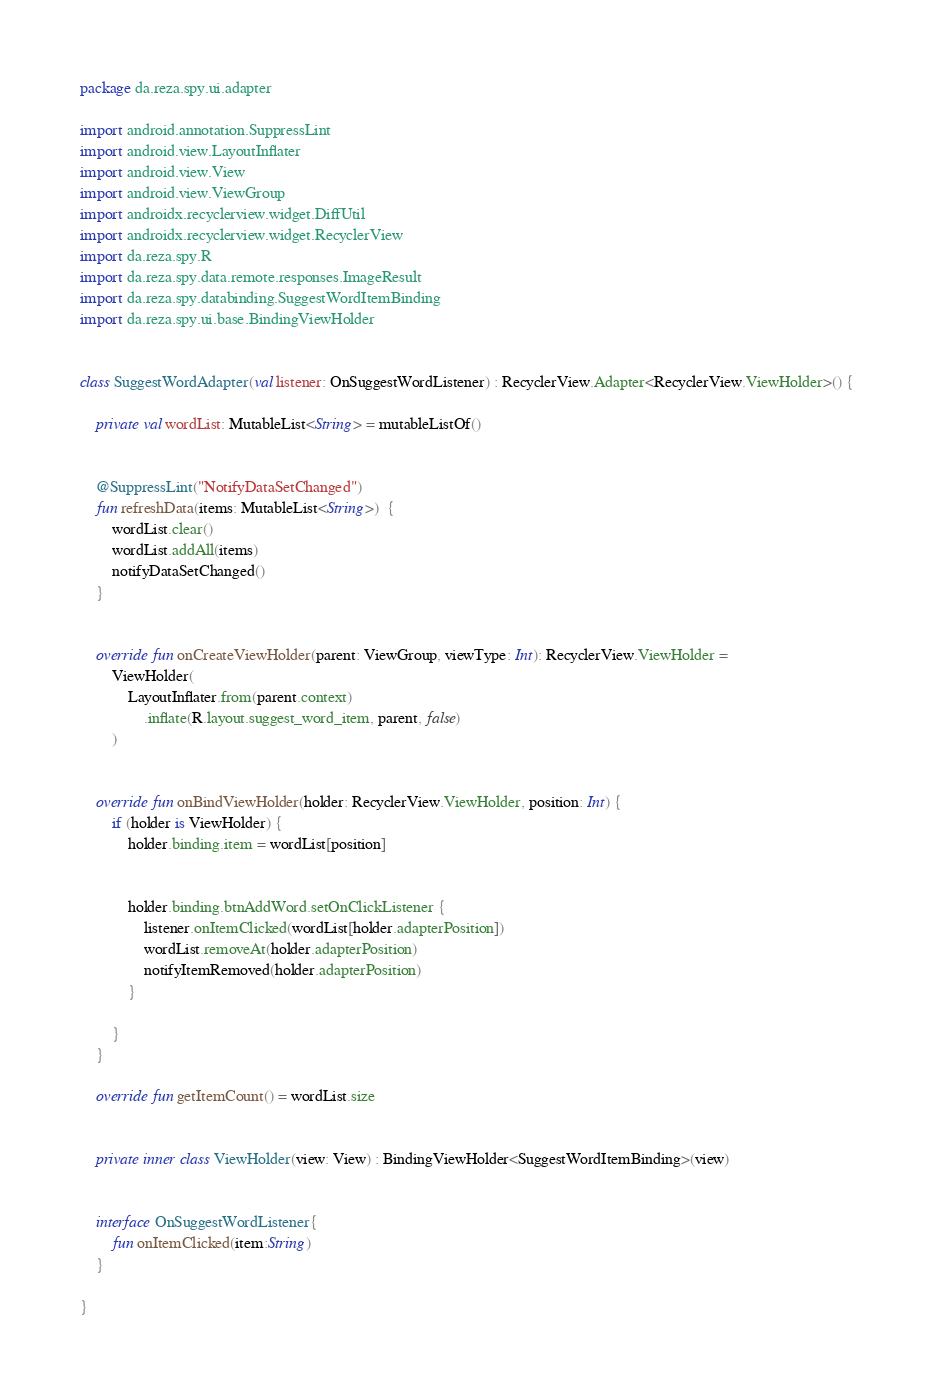Convert code to text. <code><loc_0><loc_0><loc_500><loc_500><_Kotlin_>package da.reza.spy.ui.adapter

import android.annotation.SuppressLint
import android.view.LayoutInflater
import android.view.View
import android.view.ViewGroup
import androidx.recyclerview.widget.DiffUtil
import androidx.recyclerview.widget.RecyclerView
import da.reza.spy.R
import da.reza.spy.data.remote.responses.ImageResult
import da.reza.spy.databinding.SuggestWordItemBinding
import da.reza.spy.ui.base.BindingViewHolder


class SuggestWordAdapter(val listener: OnSuggestWordListener) : RecyclerView.Adapter<RecyclerView.ViewHolder>() {

    private val wordList: MutableList<String> = mutableListOf()


    @SuppressLint("NotifyDataSetChanged")
    fun refreshData(items: MutableList<String>)  {
        wordList.clear()
        wordList.addAll(items)
        notifyDataSetChanged()
    }


    override fun onCreateViewHolder(parent: ViewGroup, viewType: Int): RecyclerView.ViewHolder =
        ViewHolder(
            LayoutInflater.from(parent.context)
                .inflate(R.layout.suggest_word_item, parent, false)
        )


    override fun onBindViewHolder(holder: RecyclerView.ViewHolder, position: Int) {
        if (holder is ViewHolder) {
            holder.binding.item = wordList[position]


            holder.binding.btnAddWord.setOnClickListener {
                listener.onItemClicked(wordList[holder.adapterPosition])
                wordList.removeAt(holder.adapterPosition)
                notifyItemRemoved(holder.adapterPosition)
            }

        }
    }

    override fun getItemCount() = wordList.size


    private inner class ViewHolder(view: View) : BindingViewHolder<SuggestWordItemBinding>(view)


    interface OnSuggestWordListener{
        fun onItemClicked(item:String)
    }

}</code> 